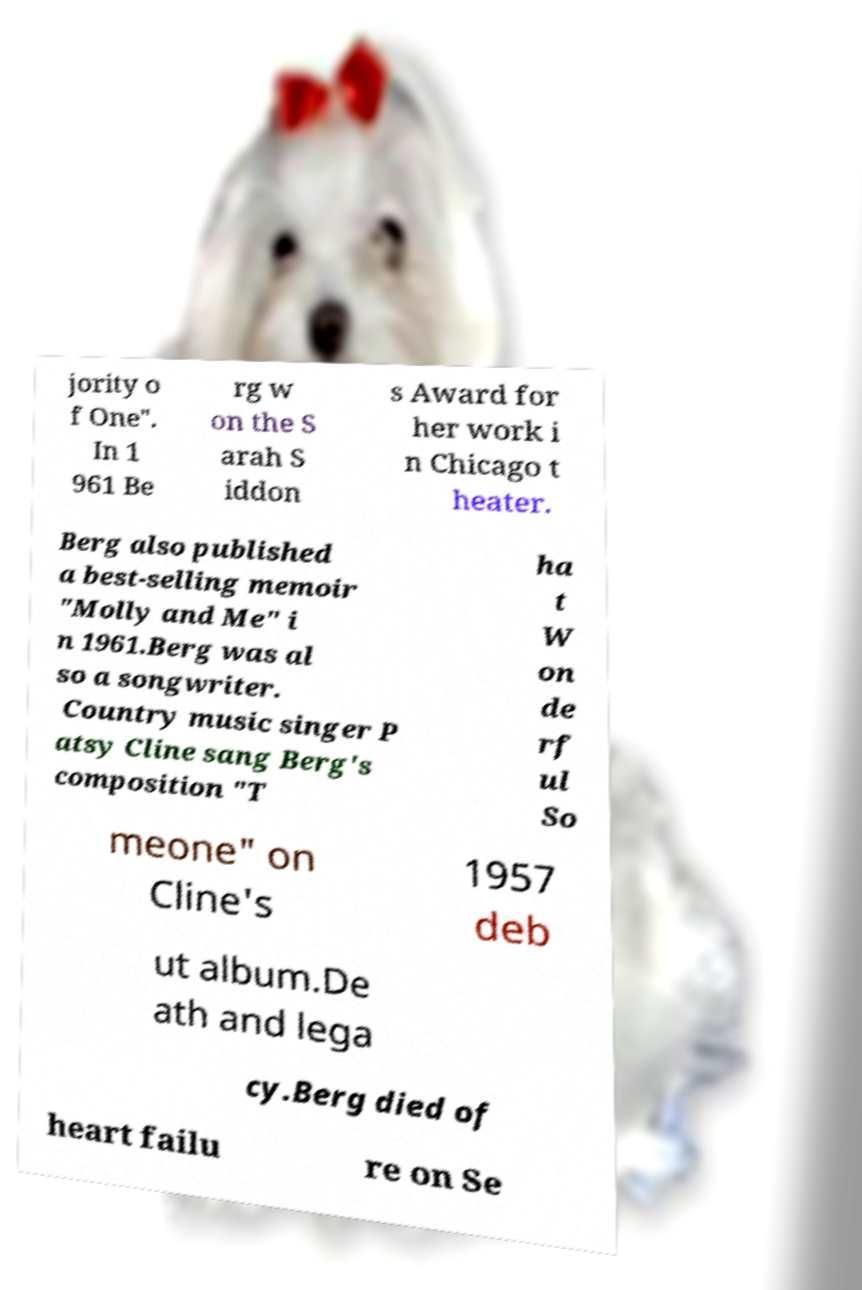What messages or text are displayed in this image? I need them in a readable, typed format. jority o f One". In 1 961 Be rg w on the S arah S iddon s Award for her work i n Chicago t heater. Berg also published a best-selling memoir "Molly and Me" i n 1961.Berg was al so a songwriter. Country music singer P atsy Cline sang Berg's composition "T ha t W on de rf ul So meone" on Cline's 1957 deb ut album.De ath and lega cy.Berg died of heart failu re on Se 